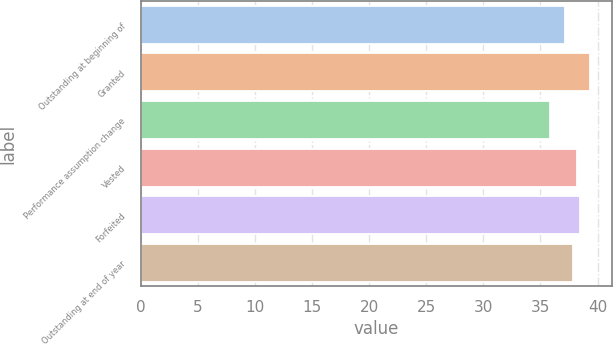Convert chart. <chart><loc_0><loc_0><loc_500><loc_500><bar_chart><fcel>Outstanding at beginning of<fcel>Granted<fcel>Performance assumption change<fcel>Vested<fcel>Forfeited<fcel>Outstanding at end of year<nl><fcel>37.11<fcel>39.32<fcel>35.87<fcel>38.16<fcel>38.5<fcel>37.82<nl></chart> 